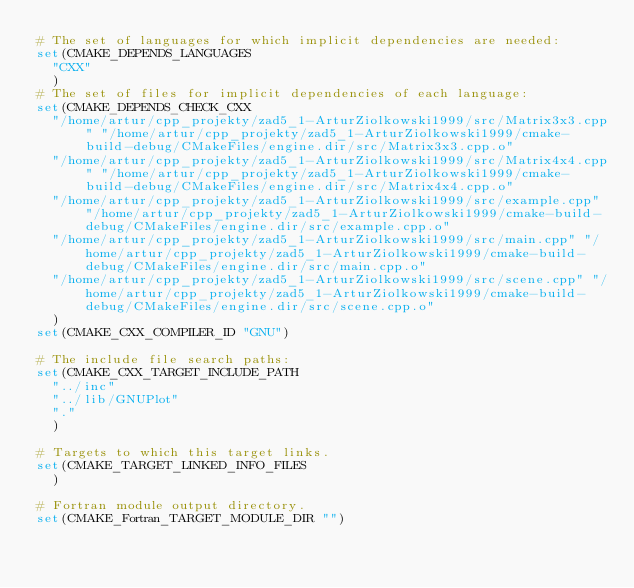Convert code to text. <code><loc_0><loc_0><loc_500><loc_500><_CMake_># The set of languages for which implicit dependencies are needed:
set(CMAKE_DEPENDS_LANGUAGES
  "CXX"
  )
# The set of files for implicit dependencies of each language:
set(CMAKE_DEPENDS_CHECK_CXX
  "/home/artur/cpp_projekty/zad5_1-ArturZiolkowski1999/src/Matrix3x3.cpp" "/home/artur/cpp_projekty/zad5_1-ArturZiolkowski1999/cmake-build-debug/CMakeFiles/engine.dir/src/Matrix3x3.cpp.o"
  "/home/artur/cpp_projekty/zad5_1-ArturZiolkowski1999/src/Matrix4x4.cpp" "/home/artur/cpp_projekty/zad5_1-ArturZiolkowski1999/cmake-build-debug/CMakeFiles/engine.dir/src/Matrix4x4.cpp.o"
  "/home/artur/cpp_projekty/zad5_1-ArturZiolkowski1999/src/example.cpp" "/home/artur/cpp_projekty/zad5_1-ArturZiolkowski1999/cmake-build-debug/CMakeFiles/engine.dir/src/example.cpp.o"
  "/home/artur/cpp_projekty/zad5_1-ArturZiolkowski1999/src/main.cpp" "/home/artur/cpp_projekty/zad5_1-ArturZiolkowski1999/cmake-build-debug/CMakeFiles/engine.dir/src/main.cpp.o"
  "/home/artur/cpp_projekty/zad5_1-ArturZiolkowski1999/src/scene.cpp" "/home/artur/cpp_projekty/zad5_1-ArturZiolkowski1999/cmake-build-debug/CMakeFiles/engine.dir/src/scene.cpp.o"
  )
set(CMAKE_CXX_COMPILER_ID "GNU")

# The include file search paths:
set(CMAKE_CXX_TARGET_INCLUDE_PATH
  "../inc"
  "../lib/GNUPlot"
  "."
  )

# Targets to which this target links.
set(CMAKE_TARGET_LINKED_INFO_FILES
  )

# Fortran module output directory.
set(CMAKE_Fortran_TARGET_MODULE_DIR "")
</code> 